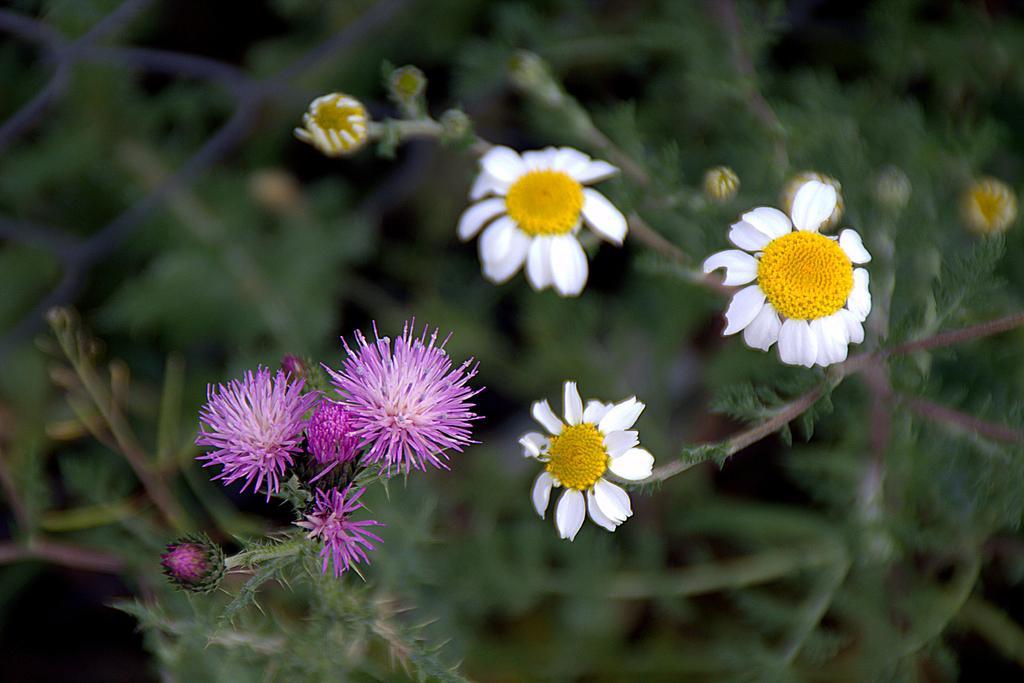Describe this image in one or two sentences. In this picture, we can see there are plants with flowers. Behind the flowers, there is the blurred background. 